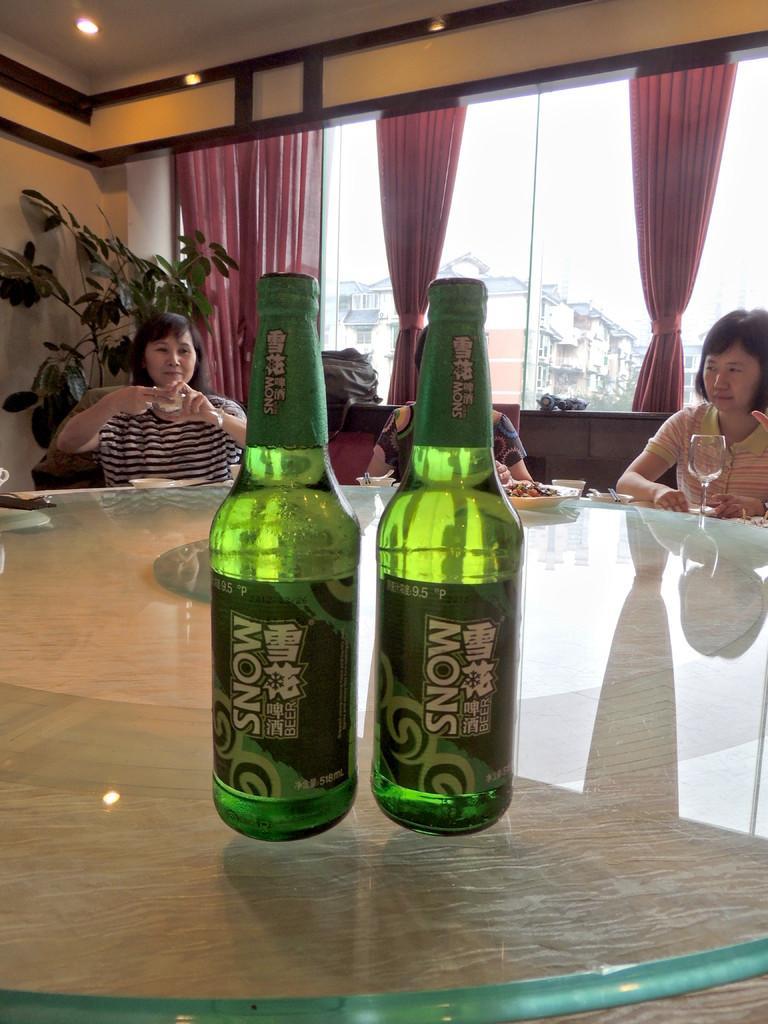Can you describe this image briefly? As we can see in the image there are curtains, window, plant, few people sitting on sofas and in the front there is a table. On table there are two bottles. 